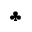<formula> <loc_0><loc_0><loc_500><loc_500>\clubsuit</formula> 